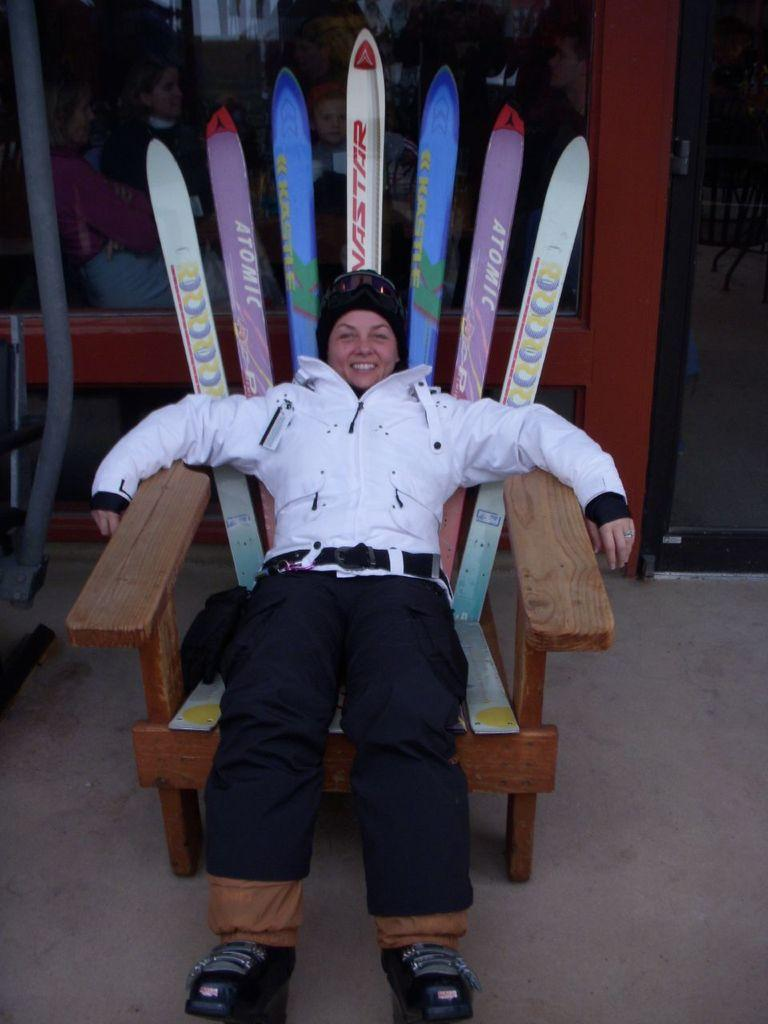Who is the main subject in the image? There is a woman in the image. What is the woman doing in the image? The woman is sitting on a chair and smiling. What is the woman wearing in the image? The woman is wearing a white jacket. Can you describe the background of the image? There are people visible in the background through mirrors. What type of mine can be seen in the background of the image? There is no mine present in the image; the background features people visible through mirrors. What kind of humor is the woman displaying in the image? The woman is smiling, but there is no specific type of humor being displayed in the image. 